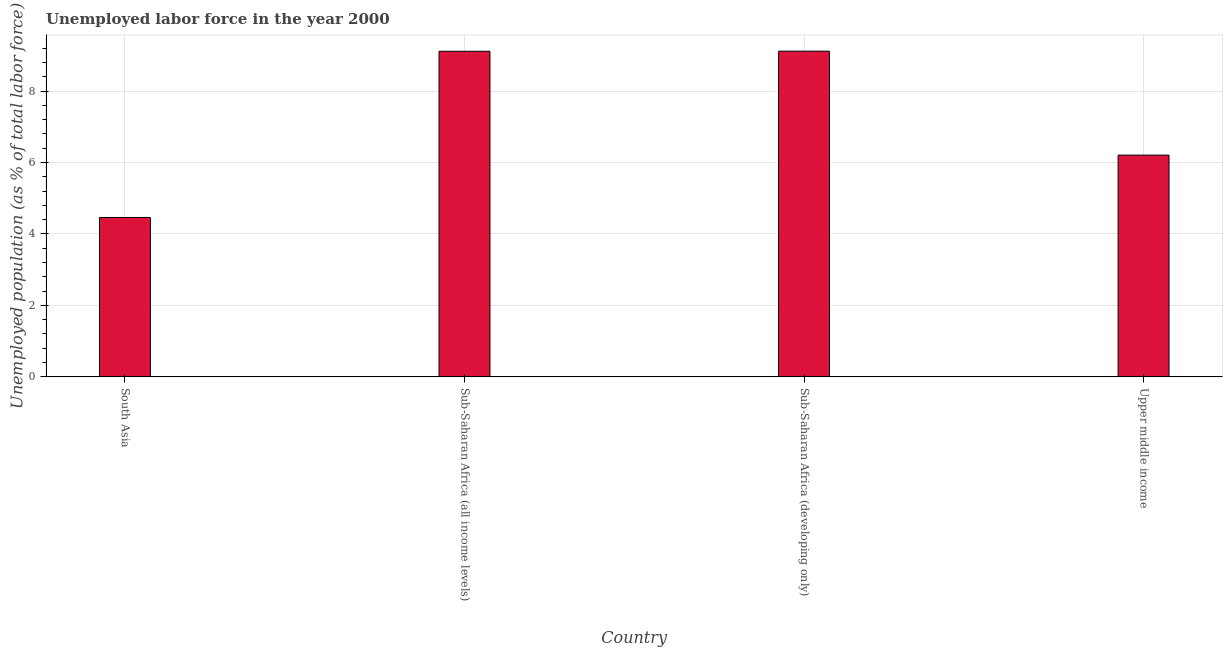Does the graph contain any zero values?
Provide a short and direct response. No. Does the graph contain grids?
Give a very brief answer. Yes. What is the title of the graph?
Provide a short and direct response. Unemployed labor force in the year 2000. What is the label or title of the Y-axis?
Give a very brief answer. Unemployed population (as % of total labor force). What is the total unemployed population in Sub-Saharan Africa (all income levels)?
Your answer should be compact. 9.11. Across all countries, what is the maximum total unemployed population?
Offer a very short reply. 9.12. Across all countries, what is the minimum total unemployed population?
Offer a very short reply. 4.46. In which country was the total unemployed population maximum?
Provide a succinct answer. Sub-Saharan Africa (developing only). What is the sum of the total unemployed population?
Give a very brief answer. 28.9. What is the difference between the total unemployed population in Sub-Saharan Africa (developing only) and Upper middle income?
Your response must be concise. 2.91. What is the average total unemployed population per country?
Make the answer very short. 7.22. What is the median total unemployed population?
Your response must be concise. 7.66. What is the ratio of the total unemployed population in South Asia to that in Upper middle income?
Keep it short and to the point. 0.72. Is the difference between the total unemployed population in South Asia and Sub-Saharan Africa (all income levels) greater than the difference between any two countries?
Give a very brief answer. No. What is the difference between the highest and the second highest total unemployed population?
Ensure brevity in your answer.  0. What is the difference between the highest and the lowest total unemployed population?
Your answer should be compact. 4.66. In how many countries, is the total unemployed population greater than the average total unemployed population taken over all countries?
Offer a terse response. 2. What is the difference between two consecutive major ticks on the Y-axis?
Keep it short and to the point. 2. Are the values on the major ticks of Y-axis written in scientific E-notation?
Offer a terse response. No. What is the Unemployed population (as % of total labor force) of South Asia?
Offer a very short reply. 4.46. What is the Unemployed population (as % of total labor force) in Sub-Saharan Africa (all income levels)?
Provide a succinct answer. 9.11. What is the Unemployed population (as % of total labor force) of Sub-Saharan Africa (developing only)?
Offer a terse response. 9.12. What is the Unemployed population (as % of total labor force) of Upper middle income?
Offer a very short reply. 6.21. What is the difference between the Unemployed population (as % of total labor force) in South Asia and Sub-Saharan Africa (all income levels)?
Offer a terse response. -4.65. What is the difference between the Unemployed population (as % of total labor force) in South Asia and Sub-Saharan Africa (developing only)?
Offer a terse response. -4.66. What is the difference between the Unemployed population (as % of total labor force) in South Asia and Upper middle income?
Provide a succinct answer. -1.75. What is the difference between the Unemployed population (as % of total labor force) in Sub-Saharan Africa (all income levels) and Sub-Saharan Africa (developing only)?
Your answer should be compact. -0. What is the difference between the Unemployed population (as % of total labor force) in Sub-Saharan Africa (all income levels) and Upper middle income?
Your response must be concise. 2.91. What is the difference between the Unemployed population (as % of total labor force) in Sub-Saharan Africa (developing only) and Upper middle income?
Ensure brevity in your answer.  2.91. What is the ratio of the Unemployed population (as % of total labor force) in South Asia to that in Sub-Saharan Africa (all income levels)?
Ensure brevity in your answer.  0.49. What is the ratio of the Unemployed population (as % of total labor force) in South Asia to that in Sub-Saharan Africa (developing only)?
Keep it short and to the point. 0.49. What is the ratio of the Unemployed population (as % of total labor force) in South Asia to that in Upper middle income?
Your response must be concise. 0.72. What is the ratio of the Unemployed population (as % of total labor force) in Sub-Saharan Africa (all income levels) to that in Upper middle income?
Provide a short and direct response. 1.47. What is the ratio of the Unemployed population (as % of total labor force) in Sub-Saharan Africa (developing only) to that in Upper middle income?
Make the answer very short. 1.47. 